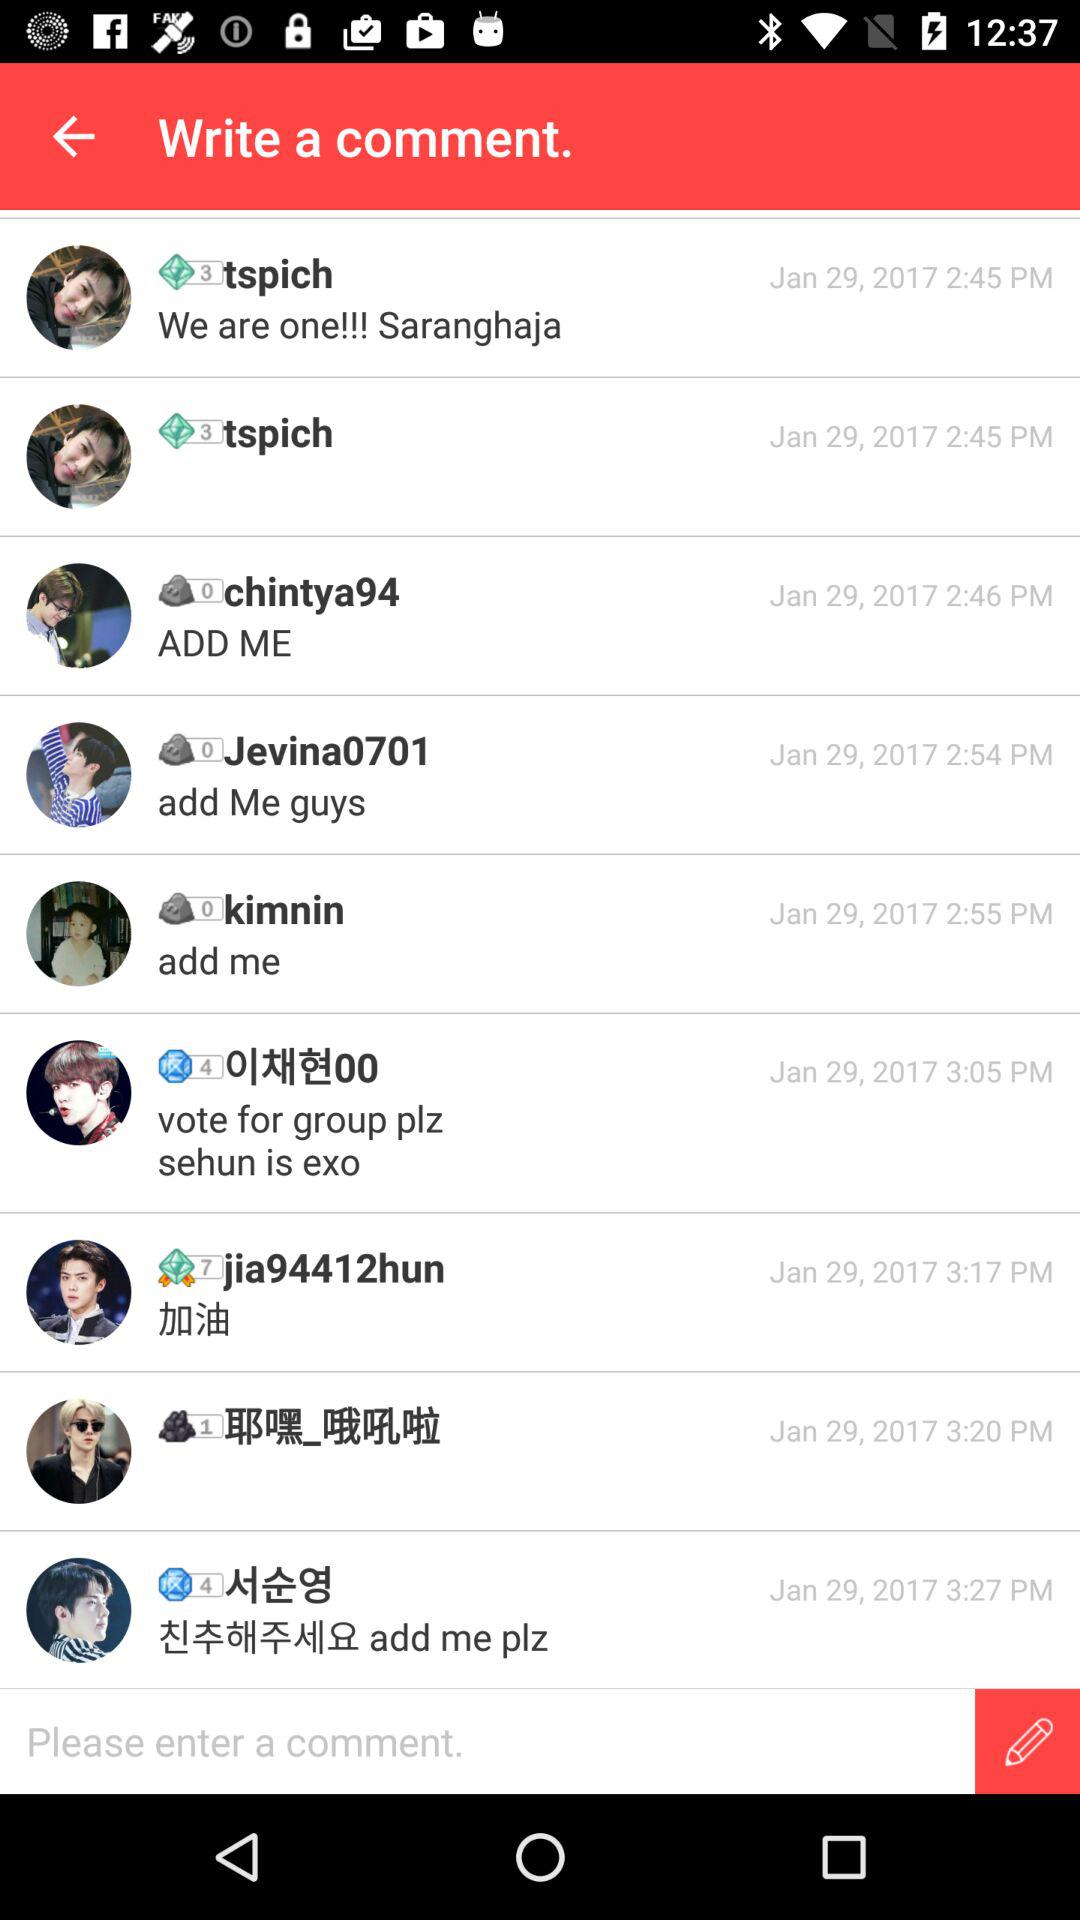When was the comment updated by tspich? The comment was updated on January 29, 2017, at 2:45 PM. 